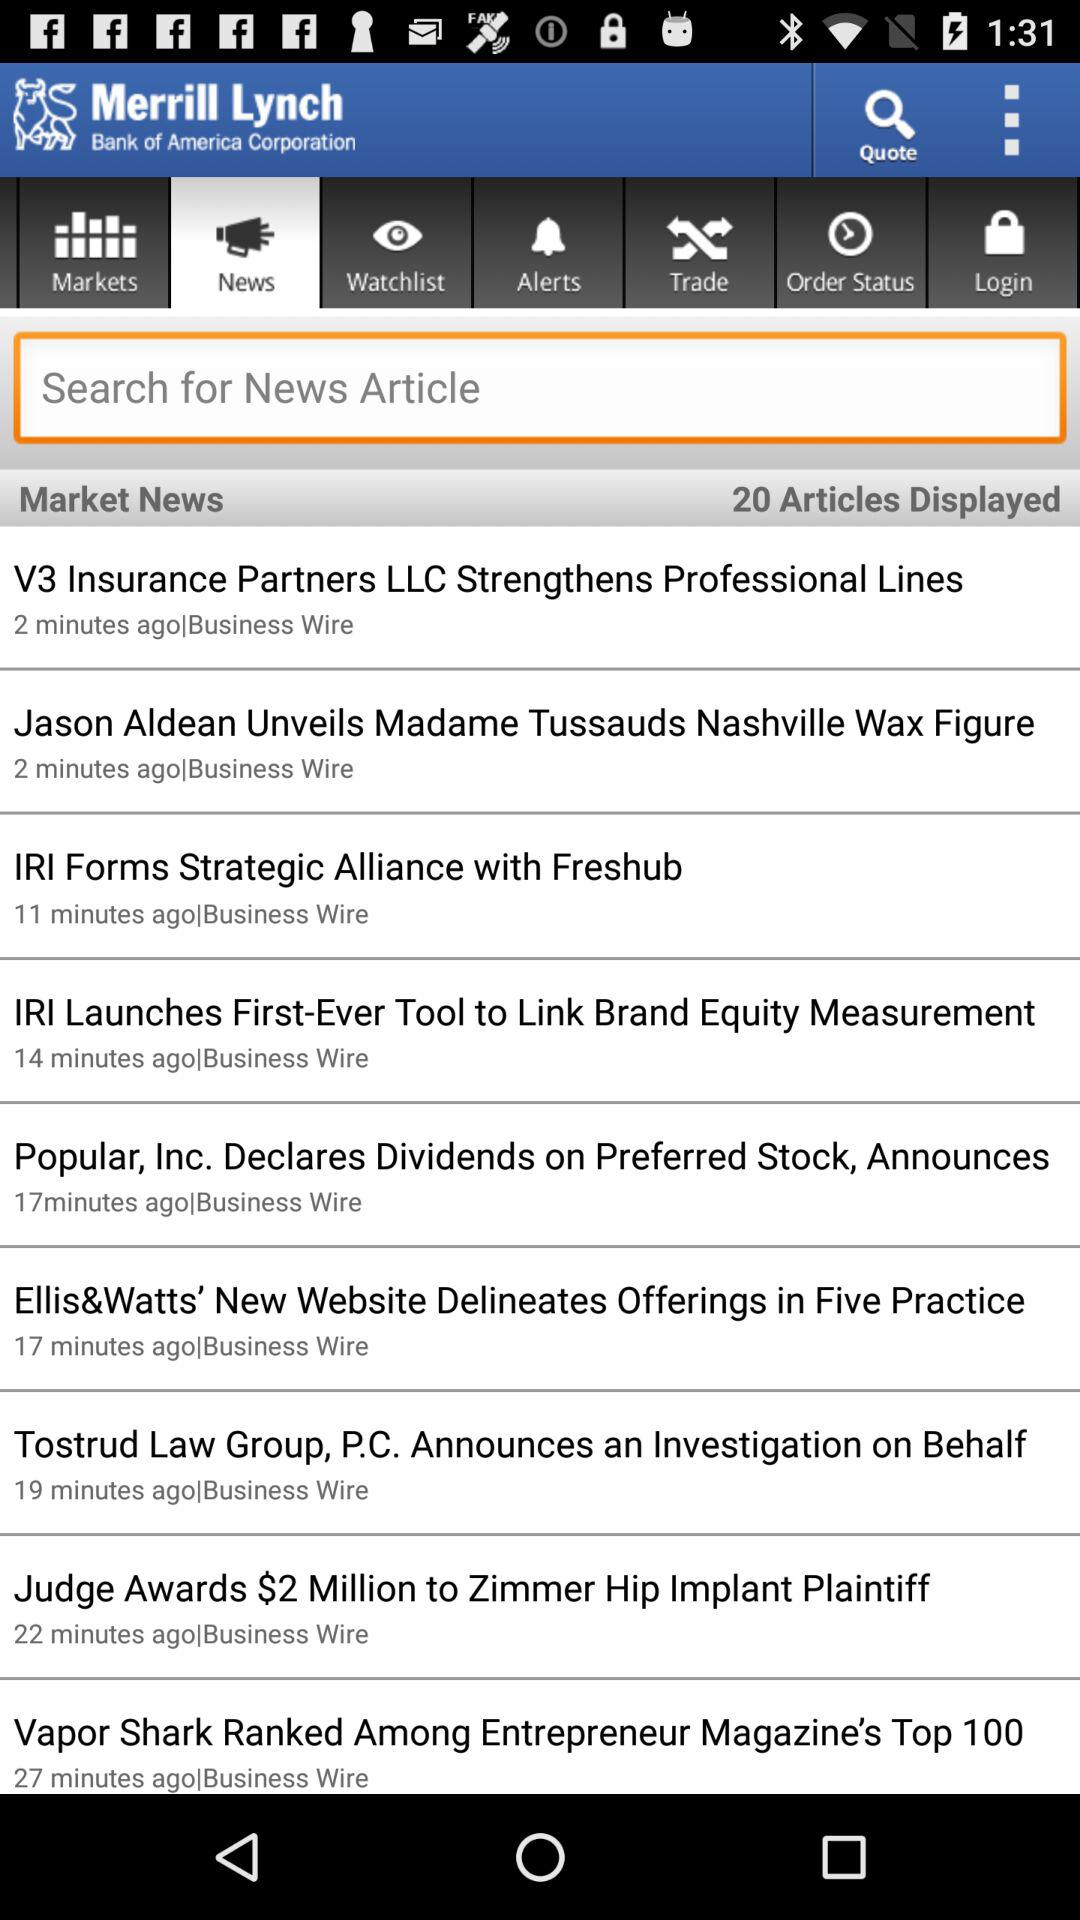Which tab is selected? The selected tab is "News". 